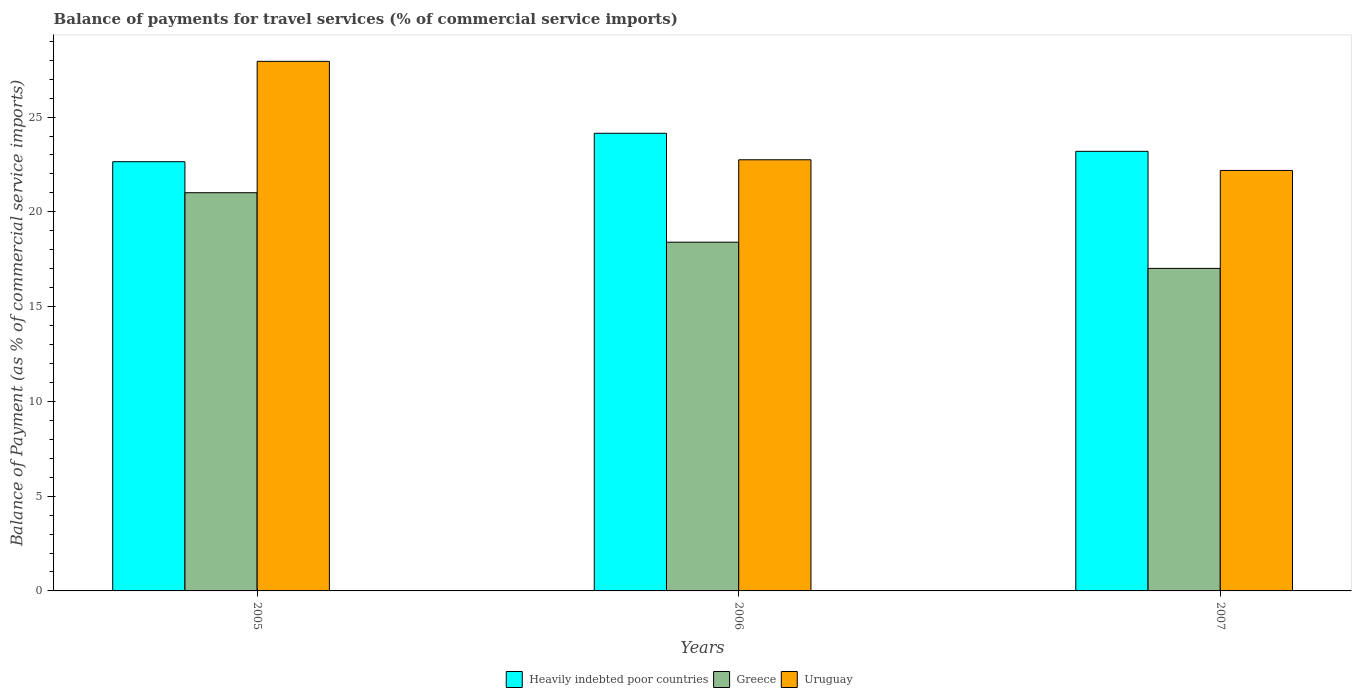Are the number of bars per tick equal to the number of legend labels?
Offer a terse response. Yes. Are the number of bars on each tick of the X-axis equal?
Provide a succinct answer. Yes. How many bars are there on the 3rd tick from the left?
Ensure brevity in your answer.  3. How many bars are there on the 2nd tick from the right?
Your answer should be very brief. 3. What is the label of the 3rd group of bars from the left?
Your answer should be very brief. 2007. What is the balance of payments for travel services in Greece in 2006?
Keep it short and to the point. 18.4. Across all years, what is the maximum balance of payments for travel services in Heavily indebted poor countries?
Give a very brief answer. 24.15. Across all years, what is the minimum balance of payments for travel services in Greece?
Give a very brief answer. 17.02. In which year was the balance of payments for travel services in Greece maximum?
Keep it short and to the point. 2005. In which year was the balance of payments for travel services in Heavily indebted poor countries minimum?
Your answer should be compact. 2005. What is the total balance of payments for travel services in Uruguay in the graph?
Your answer should be compact. 72.87. What is the difference between the balance of payments for travel services in Heavily indebted poor countries in 2006 and that in 2007?
Provide a succinct answer. 0.95. What is the difference between the balance of payments for travel services in Uruguay in 2005 and the balance of payments for travel services in Heavily indebted poor countries in 2006?
Make the answer very short. 3.79. What is the average balance of payments for travel services in Heavily indebted poor countries per year?
Offer a terse response. 23.33. In the year 2006, what is the difference between the balance of payments for travel services in Heavily indebted poor countries and balance of payments for travel services in Uruguay?
Ensure brevity in your answer.  1.4. In how many years, is the balance of payments for travel services in Heavily indebted poor countries greater than 21 %?
Your answer should be very brief. 3. What is the ratio of the balance of payments for travel services in Uruguay in 2006 to that in 2007?
Offer a terse response. 1.03. Is the balance of payments for travel services in Heavily indebted poor countries in 2005 less than that in 2007?
Make the answer very short. Yes. Is the difference between the balance of payments for travel services in Heavily indebted poor countries in 2006 and 2007 greater than the difference between the balance of payments for travel services in Uruguay in 2006 and 2007?
Your response must be concise. Yes. What is the difference between the highest and the second highest balance of payments for travel services in Greece?
Ensure brevity in your answer.  2.61. What is the difference between the highest and the lowest balance of payments for travel services in Uruguay?
Ensure brevity in your answer.  5.76. In how many years, is the balance of payments for travel services in Uruguay greater than the average balance of payments for travel services in Uruguay taken over all years?
Keep it short and to the point. 1. What does the 2nd bar from the left in 2005 represents?
Your response must be concise. Greece. Is it the case that in every year, the sum of the balance of payments for travel services in Uruguay and balance of payments for travel services in Greece is greater than the balance of payments for travel services in Heavily indebted poor countries?
Offer a very short reply. Yes. How many years are there in the graph?
Offer a terse response. 3. How many legend labels are there?
Keep it short and to the point. 3. What is the title of the graph?
Make the answer very short. Balance of payments for travel services (% of commercial service imports). Does "Romania" appear as one of the legend labels in the graph?
Your answer should be very brief. No. What is the label or title of the Y-axis?
Give a very brief answer. Balance of Payment (as % of commercial service imports). What is the Balance of Payment (as % of commercial service imports) of Heavily indebted poor countries in 2005?
Keep it short and to the point. 22.65. What is the Balance of Payment (as % of commercial service imports) in Greece in 2005?
Provide a succinct answer. 21.01. What is the Balance of Payment (as % of commercial service imports) in Uruguay in 2005?
Provide a succinct answer. 27.94. What is the Balance of Payment (as % of commercial service imports) of Heavily indebted poor countries in 2006?
Your response must be concise. 24.15. What is the Balance of Payment (as % of commercial service imports) in Greece in 2006?
Give a very brief answer. 18.4. What is the Balance of Payment (as % of commercial service imports) in Uruguay in 2006?
Ensure brevity in your answer.  22.75. What is the Balance of Payment (as % of commercial service imports) of Heavily indebted poor countries in 2007?
Your answer should be very brief. 23.19. What is the Balance of Payment (as % of commercial service imports) of Greece in 2007?
Make the answer very short. 17.02. What is the Balance of Payment (as % of commercial service imports) of Uruguay in 2007?
Your answer should be very brief. 22.18. Across all years, what is the maximum Balance of Payment (as % of commercial service imports) in Heavily indebted poor countries?
Give a very brief answer. 24.15. Across all years, what is the maximum Balance of Payment (as % of commercial service imports) of Greece?
Offer a very short reply. 21.01. Across all years, what is the maximum Balance of Payment (as % of commercial service imports) of Uruguay?
Your answer should be compact. 27.94. Across all years, what is the minimum Balance of Payment (as % of commercial service imports) of Heavily indebted poor countries?
Keep it short and to the point. 22.65. Across all years, what is the minimum Balance of Payment (as % of commercial service imports) in Greece?
Give a very brief answer. 17.02. Across all years, what is the minimum Balance of Payment (as % of commercial service imports) of Uruguay?
Give a very brief answer. 22.18. What is the total Balance of Payment (as % of commercial service imports) in Heavily indebted poor countries in the graph?
Your response must be concise. 69.99. What is the total Balance of Payment (as % of commercial service imports) in Greece in the graph?
Provide a short and direct response. 56.43. What is the total Balance of Payment (as % of commercial service imports) in Uruguay in the graph?
Provide a short and direct response. 72.87. What is the difference between the Balance of Payment (as % of commercial service imports) in Heavily indebted poor countries in 2005 and that in 2006?
Your response must be concise. -1.5. What is the difference between the Balance of Payment (as % of commercial service imports) in Greece in 2005 and that in 2006?
Keep it short and to the point. 2.61. What is the difference between the Balance of Payment (as % of commercial service imports) of Uruguay in 2005 and that in 2006?
Provide a succinct answer. 5.19. What is the difference between the Balance of Payment (as % of commercial service imports) in Heavily indebted poor countries in 2005 and that in 2007?
Provide a succinct answer. -0.55. What is the difference between the Balance of Payment (as % of commercial service imports) in Greece in 2005 and that in 2007?
Give a very brief answer. 3.99. What is the difference between the Balance of Payment (as % of commercial service imports) of Uruguay in 2005 and that in 2007?
Give a very brief answer. 5.76. What is the difference between the Balance of Payment (as % of commercial service imports) of Heavily indebted poor countries in 2006 and that in 2007?
Give a very brief answer. 0.95. What is the difference between the Balance of Payment (as % of commercial service imports) in Greece in 2006 and that in 2007?
Your answer should be very brief. 1.38. What is the difference between the Balance of Payment (as % of commercial service imports) of Uruguay in 2006 and that in 2007?
Offer a terse response. 0.56. What is the difference between the Balance of Payment (as % of commercial service imports) in Heavily indebted poor countries in 2005 and the Balance of Payment (as % of commercial service imports) in Greece in 2006?
Your answer should be very brief. 4.25. What is the difference between the Balance of Payment (as % of commercial service imports) in Heavily indebted poor countries in 2005 and the Balance of Payment (as % of commercial service imports) in Uruguay in 2006?
Give a very brief answer. -0.1. What is the difference between the Balance of Payment (as % of commercial service imports) of Greece in 2005 and the Balance of Payment (as % of commercial service imports) of Uruguay in 2006?
Give a very brief answer. -1.74. What is the difference between the Balance of Payment (as % of commercial service imports) in Heavily indebted poor countries in 2005 and the Balance of Payment (as % of commercial service imports) in Greece in 2007?
Make the answer very short. 5.63. What is the difference between the Balance of Payment (as % of commercial service imports) of Heavily indebted poor countries in 2005 and the Balance of Payment (as % of commercial service imports) of Uruguay in 2007?
Give a very brief answer. 0.46. What is the difference between the Balance of Payment (as % of commercial service imports) of Greece in 2005 and the Balance of Payment (as % of commercial service imports) of Uruguay in 2007?
Offer a very short reply. -1.17. What is the difference between the Balance of Payment (as % of commercial service imports) of Heavily indebted poor countries in 2006 and the Balance of Payment (as % of commercial service imports) of Greece in 2007?
Give a very brief answer. 7.13. What is the difference between the Balance of Payment (as % of commercial service imports) in Heavily indebted poor countries in 2006 and the Balance of Payment (as % of commercial service imports) in Uruguay in 2007?
Offer a terse response. 1.96. What is the difference between the Balance of Payment (as % of commercial service imports) of Greece in 2006 and the Balance of Payment (as % of commercial service imports) of Uruguay in 2007?
Offer a terse response. -3.79. What is the average Balance of Payment (as % of commercial service imports) in Heavily indebted poor countries per year?
Give a very brief answer. 23.33. What is the average Balance of Payment (as % of commercial service imports) in Greece per year?
Your answer should be very brief. 18.81. What is the average Balance of Payment (as % of commercial service imports) in Uruguay per year?
Your response must be concise. 24.29. In the year 2005, what is the difference between the Balance of Payment (as % of commercial service imports) of Heavily indebted poor countries and Balance of Payment (as % of commercial service imports) of Greece?
Offer a terse response. 1.64. In the year 2005, what is the difference between the Balance of Payment (as % of commercial service imports) of Heavily indebted poor countries and Balance of Payment (as % of commercial service imports) of Uruguay?
Provide a short and direct response. -5.29. In the year 2005, what is the difference between the Balance of Payment (as % of commercial service imports) of Greece and Balance of Payment (as % of commercial service imports) of Uruguay?
Your answer should be compact. -6.93. In the year 2006, what is the difference between the Balance of Payment (as % of commercial service imports) in Heavily indebted poor countries and Balance of Payment (as % of commercial service imports) in Greece?
Ensure brevity in your answer.  5.75. In the year 2006, what is the difference between the Balance of Payment (as % of commercial service imports) of Heavily indebted poor countries and Balance of Payment (as % of commercial service imports) of Uruguay?
Your answer should be compact. 1.4. In the year 2006, what is the difference between the Balance of Payment (as % of commercial service imports) in Greece and Balance of Payment (as % of commercial service imports) in Uruguay?
Provide a short and direct response. -4.35. In the year 2007, what is the difference between the Balance of Payment (as % of commercial service imports) of Heavily indebted poor countries and Balance of Payment (as % of commercial service imports) of Greece?
Provide a short and direct response. 6.18. In the year 2007, what is the difference between the Balance of Payment (as % of commercial service imports) in Heavily indebted poor countries and Balance of Payment (as % of commercial service imports) in Uruguay?
Your response must be concise. 1.01. In the year 2007, what is the difference between the Balance of Payment (as % of commercial service imports) of Greece and Balance of Payment (as % of commercial service imports) of Uruguay?
Offer a very short reply. -5.17. What is the ratio of the Balance of Payment (as % of commercial service imports) of Heavily indebted poor countries in 2005 to that in 2006?
Your answer should be compact. 0.94. What is the ratio of the Balance of Payment (as % of commercial service imports) of Greece in 2005 to that in 2006?
Offer a terse response. 1.14. What is the ratio of the Balance of Payment (as % of commercial service imports) of Uruguay in 2005 to that in 2006?
Your answer should be very brief. 1.23. What is the ratio of the Balance of Payment (as % of commercial service imports) in Heavily indebted poor countries in 2005 to that in 2007?
Your answer should be very brief. 0.98. What is the ratio of the Balance of Payment (as % of commercial service imports) of Greece in 2005 to that in 2007?
Ensure brevity in your answer.  1.23. What is the ratio of the Balance of Payment (as % of commercial service imports) in Uruguay in 2005 to that in 2007?
Provide a short and direct response. 1.26. What is the ratio of the Balance of Payment (as % of commercial service imports) of Heavily indebted poor countries in 2006 to that in 2007?
Make the answer very short. 1.04. What is the ratio of the Balance of Payment (as % of commercial service imports) of Greece in 2006 to that in 2007?
Ensure brevity in your answer.  1.08. What is the ratio of the Balance of Payment (as % of commercial service imports) of Uruguay in 2006 to that in 2007?
Ensure brevity in your answer.  1.03. What is the difference between the highest and the second highest Balance of Payment (as % of commercial service imports) in Heavily indebted poor countries?
Give a very brief answer. 0.95. What is the difference between the highest and the second highest Balance of Payment (as % of commercial service imports) in Greece?
Provide a short and direct response. 2.61. What is the difference between the highest and the second highest Balance of Payment (as % of commercial service imports) in Uruguay?
Provide a short and direct response. 5.19. What is the difference between the highest and the lowest Balance of Payment (as % of commercial service imports) in Heavily indebted poor countries?
Ensure brevity in your answer.  1.5. What is the difference between the highest and the lowest Balance of Payment (as % of commercial service imports) in Greece?
Ensure brevity in your answer.  3.99. What is the difference between the highest and the lowest Balance of Payment (as % of commercial service imports) in Uruguay?
Offer a terse response. 5.76. 